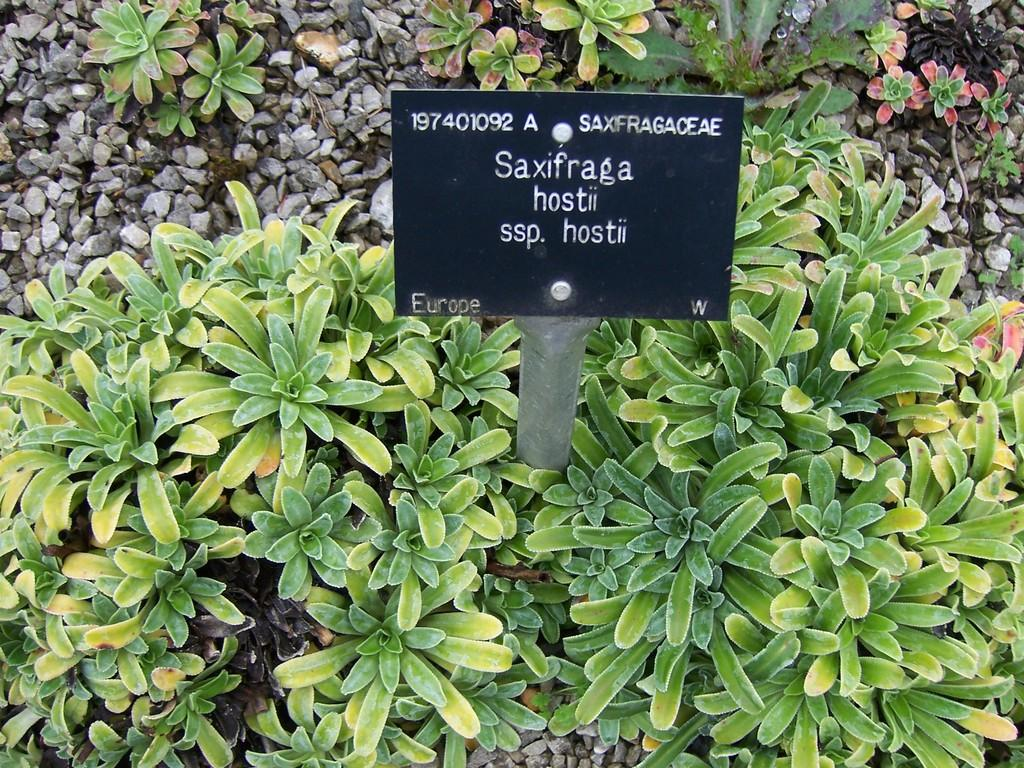What type of living organisms can be seen in the image? Plants can be seen in the image. What type of material is present in the image? Stones and a metal rod are present in the image. What is the flat, rigid surface in the image? There is a board in the image. Reasoning: Let' Let's think step by step in order to produce the conversation. We start by identifying the main subjects in the image, which are the plants. Then, we expand the conversation to include other items that are also visible, such as stones, a metal rod, and a board. Each question is designed to elicit a specific detail about the image that is known from the provided facts. Absurd Question/Answer: What is the taste of the furniture in the image? There is no furniture present in the image, and therefore, it cannot have a taste. 